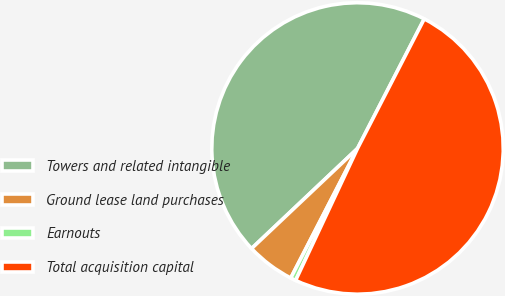Convert chart to OTSL. <chart><loc_0><loc_0><loc_500><loc_500><pie_chart><fcel>Towers and related intangible<fcel>Ground lease land purchases<fcel>Earnouts<fcel>Total acquisition capital<nl><fcel>44.62%<fcel>5.38%<fcel>0.59%<fcel>49.41%<nl></chart> 